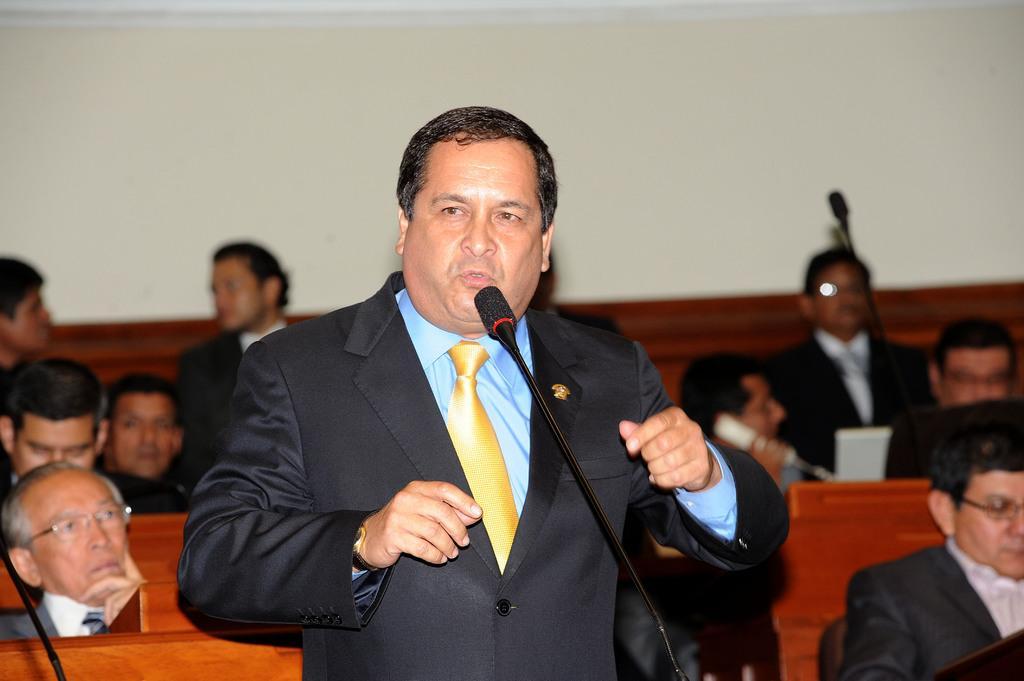Describe this image in one or two sentences. This picture might be taken inside the room. In this image, in the middle, we can see a person standing and talking in front of a microphone. On the right side, we can see a group of people sitting on the chair in front of the table, at that table, we can see a microphone, landline. On the left side, we can also see a group of people sitting on the chair in front of the table, at that table, we can see a microphone. In the background, we can see a wall. 